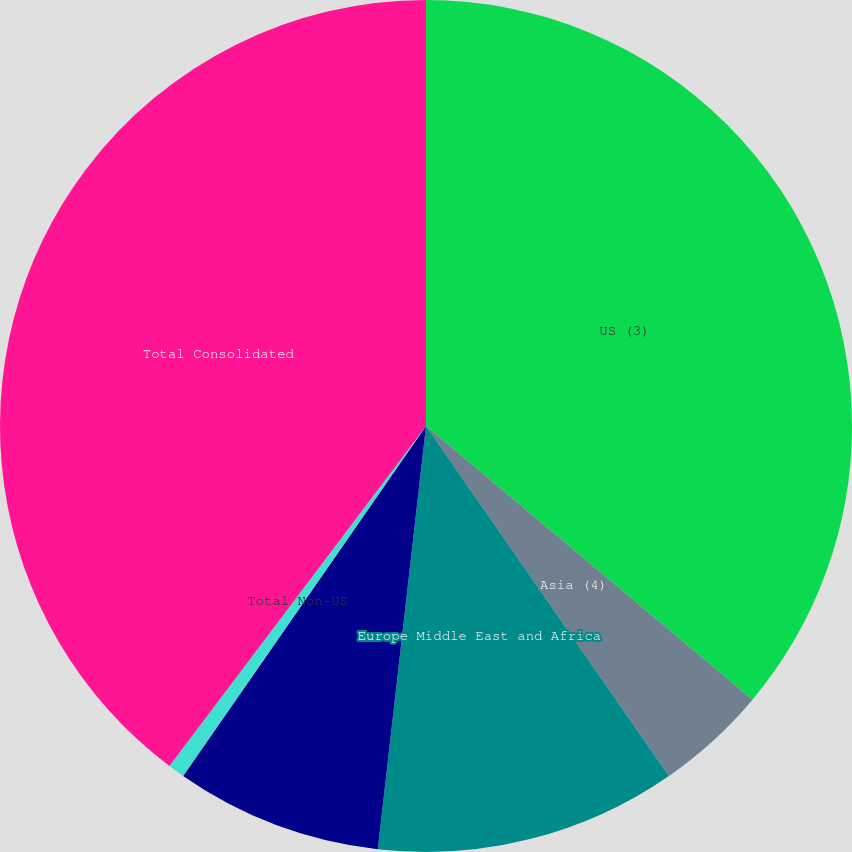Convert chart to OTSL. <chart><loc_0><loc_0><loc_500><loc_500><pie_chart><fcel>US (3)<fcel>Asia (4)<fcel>Europe Middle East and Africa<fcel>Latin America and the<fcel>Total Non-US<fcel>Total Consolidated<nl><fcel>36.1%<fcel>4.24%<fcel>11.46%<fcel>7.85%<fcel>0.63%<fcel>39.71%<nl></chart> 